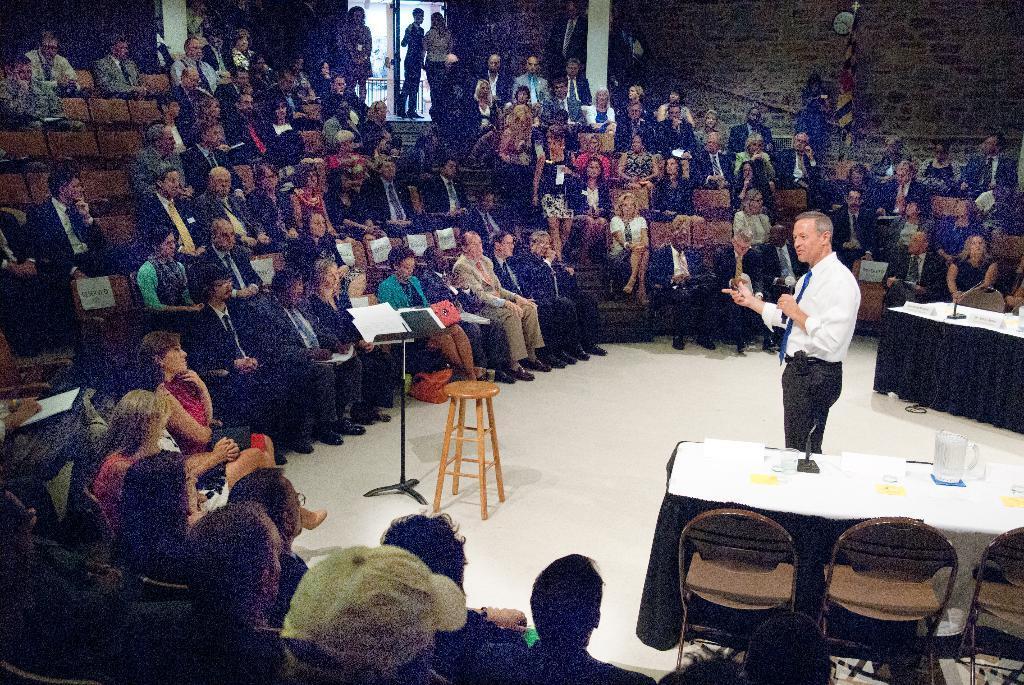In one or two sentences, can you explain what this image depicts? There is a group of people who are sitting on a chair. There is a person standing on the right side. He is holding a microphone in his hand and he is speaking. 